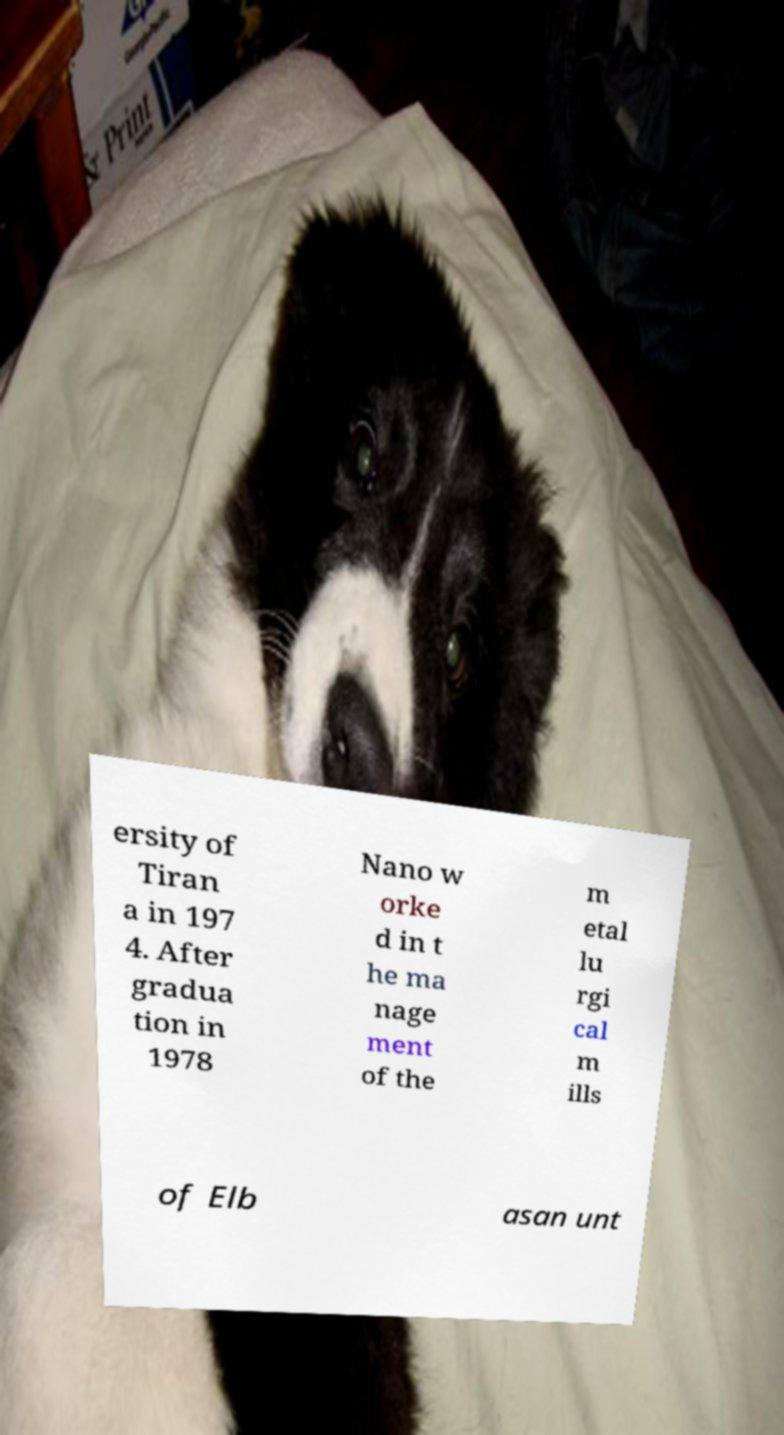There's text embedded in this image that I need extracted. Can you transcribe it verbatim? ersity of Tiran a in 197 4. After gradua tion in 1978 Nano w orke d in t he ma nage ment of the m etal lu rgi cal m ills of Elb asan unt 